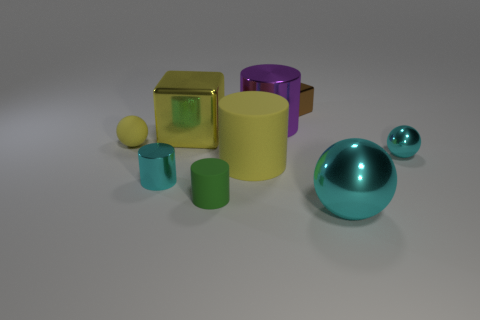There is a cylinder that is the same color as the large block; what is its size?
Give a very brief answer. Large. How many objects are objects or cyan cubes?
Provide a short and direct response. 9. What color is the metallic cylinder that is the same size as the brown block?
Your answer should be very brief. Cyan. There is a green rubber object; is it the same shape as the small metallic object that is to the left of the small cube?
Offer a terse response. Yes. How many objects are either small objects that are behind the small green rubber object or small cyan metallic things to the left of the big purple metallic thing?
Provide a short and direct response. 4. What shape is the large metal thing that is the same color as the matte sphere?
Offer a very short reply. Cube. There is a cyan metal thing that is behind the tiny metallic cylinder; what shape is it?
Keep it short and to the point. Sphere. There is a cyan thing on the left side of the small green matte cylinder; is it the same shape as the large rubber object?
Keep it short and to the point. Yes. What number of objects are either yellow objects right of the yellow metal block or brown matte cylinders?
Offer a very short reply. 1. There is another small shiny object that is the same shape as the small yellow thing; what color is it?
Your response must be concise. Cyan. 